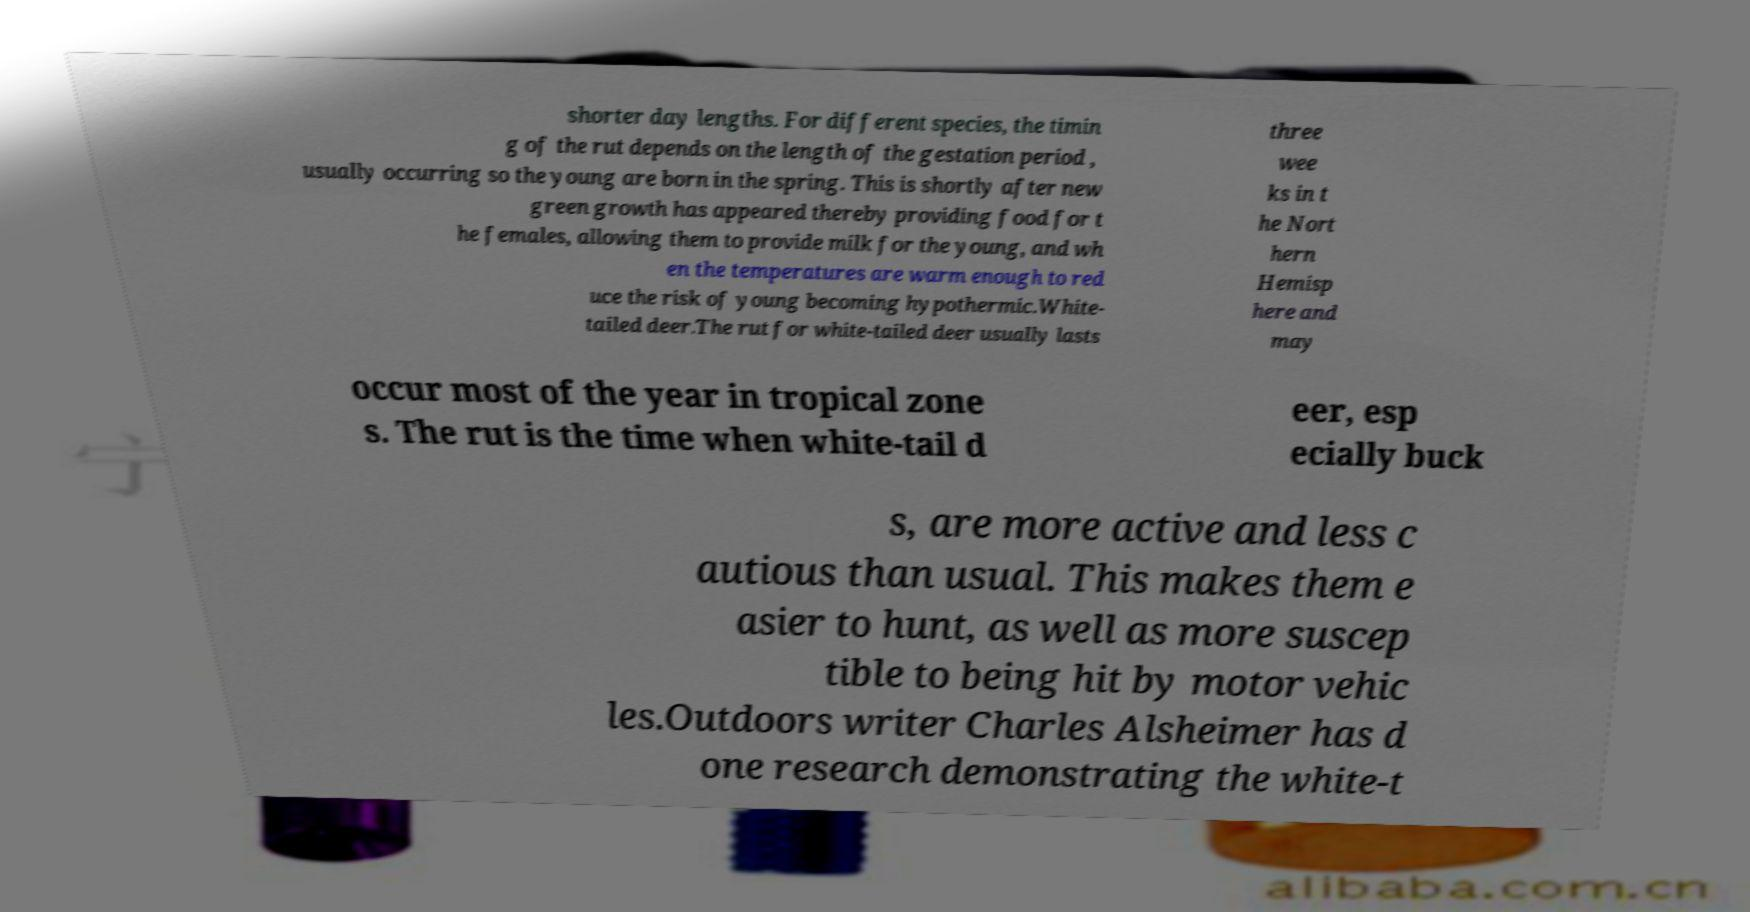Could you extract and type out the text from this image? shorter day lengths. For different species, the timin g of the rut depends on the length of the gestation period , usually occurring so the young are born in the spring. This is shortly after new green growth has appeared thereby providing food for t he females, allowing them to provide milk for the young, and wh en the temperatures are warm enough to red uce the risk of young becoming hypothermic.White- tailed deer.The rut for white-tailed deer usually lasts three wee ks in t he Nort hern Hemisp here and may occur most of the year in tropical zone s. The rut is the time when white-tail d eer, esp ecially buck s, are more active and less c autious than usual. This makes them e asier to hunt, as well as more suscep tible to being hit by motor vehic les.Outdoors writer Charles Alsheimer has d one research demonstrating the white-t 